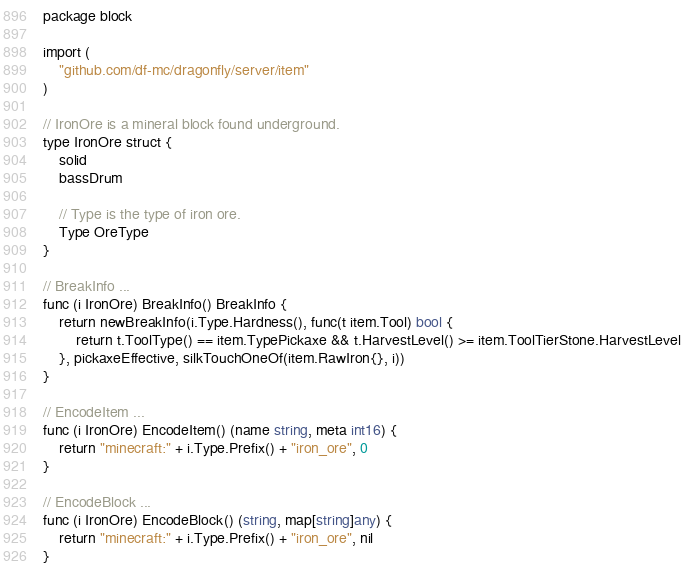<code> <loc_0><loc_0><loc_500><loc_500><_Go_>package block

import (
	"github.com/df-mc/dragonfly/server/item"
)

// IronOre is a mineral block found underground.
type IronOre struct {
	solid
	bassDrum

	// Type is the type of iron ore.
	Type OreType
}

// BreakInfo ...
func (i IronOre) BreakInfo() BreakInfo {
	return newBreakInfo(i.Type.Hardness(), func(t item.Tool) bool {
		return t.ToolType() == item.TypePickaxe && t.HarvestLevel() >= item.ToolTierStone.HarvestLevel
	}, pickaxeEffective, silkTouchOneOf(item.RawIron{}, i))
}

// EncodeItem ...
func (i IronOre) EncodeItem() (name string, meta int16) {
	return "minecraft:" + i.Type.Prefix() + "iron_ore", 0
}

// EncodeBlock ...
func (i IronOre) EncodeBlock() (string, map[string]any) {
	return "minecraft:" + i.Type.Prefix() + "iron_ore", nil
}
</code> 